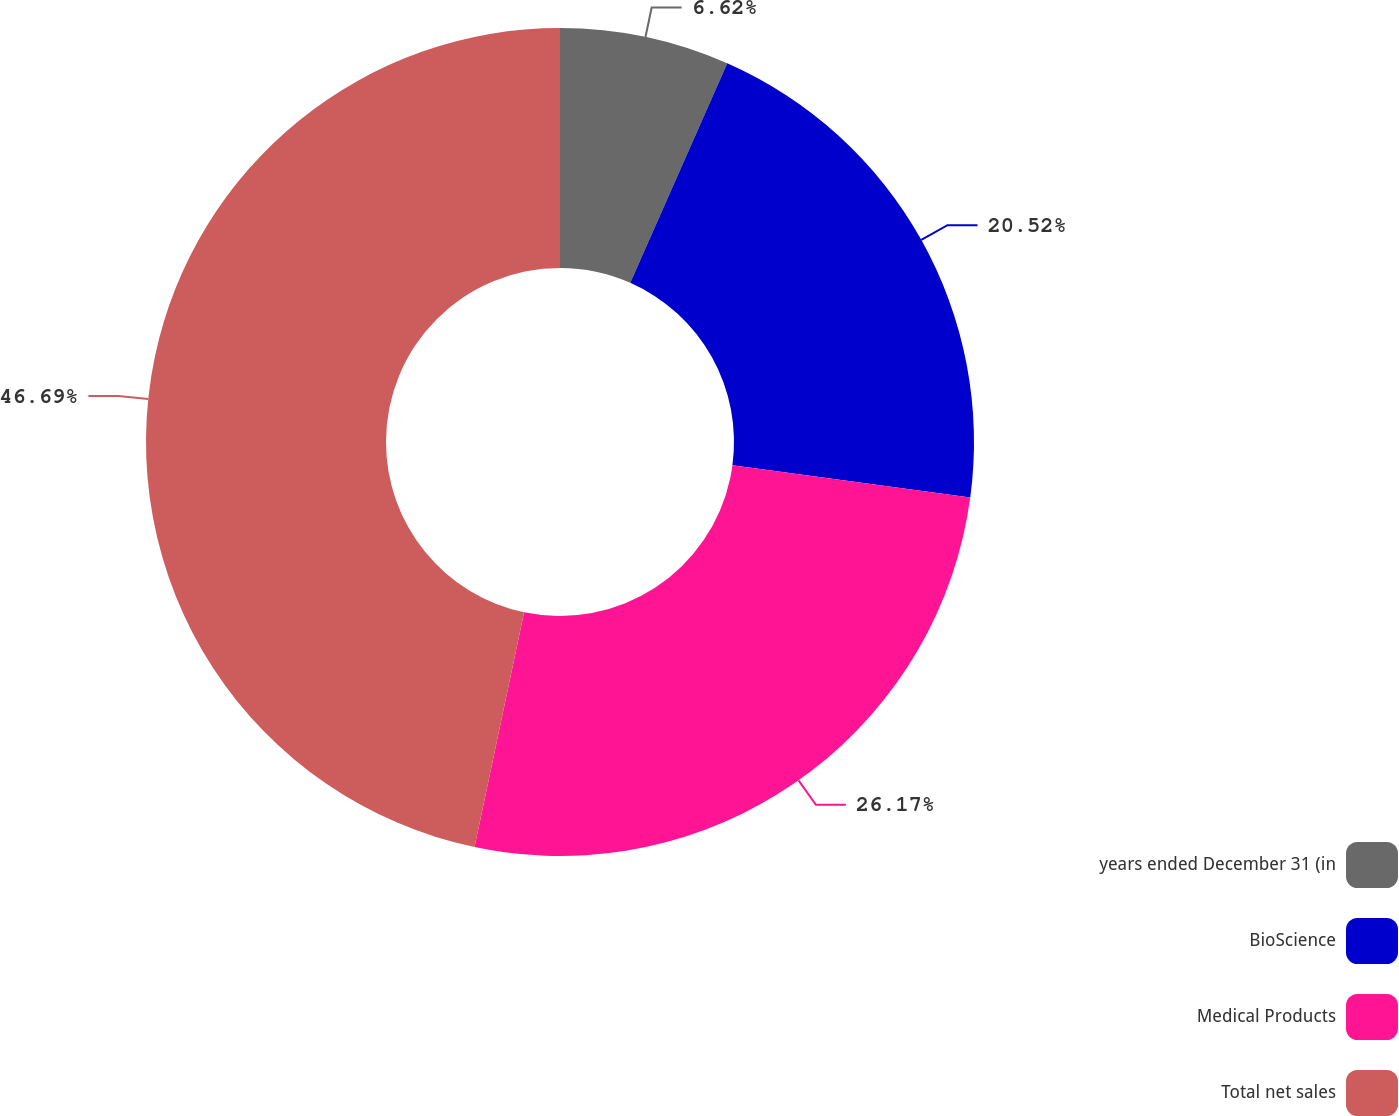Convert chart. <chart><loc_0><loc_0><loc_500><loc_500><pie_chart><fcel>years ended December 31 (in<fcel>BioScience<fcel>Medical Products<fcel>Total net sales<nl><fcel>6.62%<fcel>20.52%<fcel>26.17%<fcel>46.69%<nl></chart> 